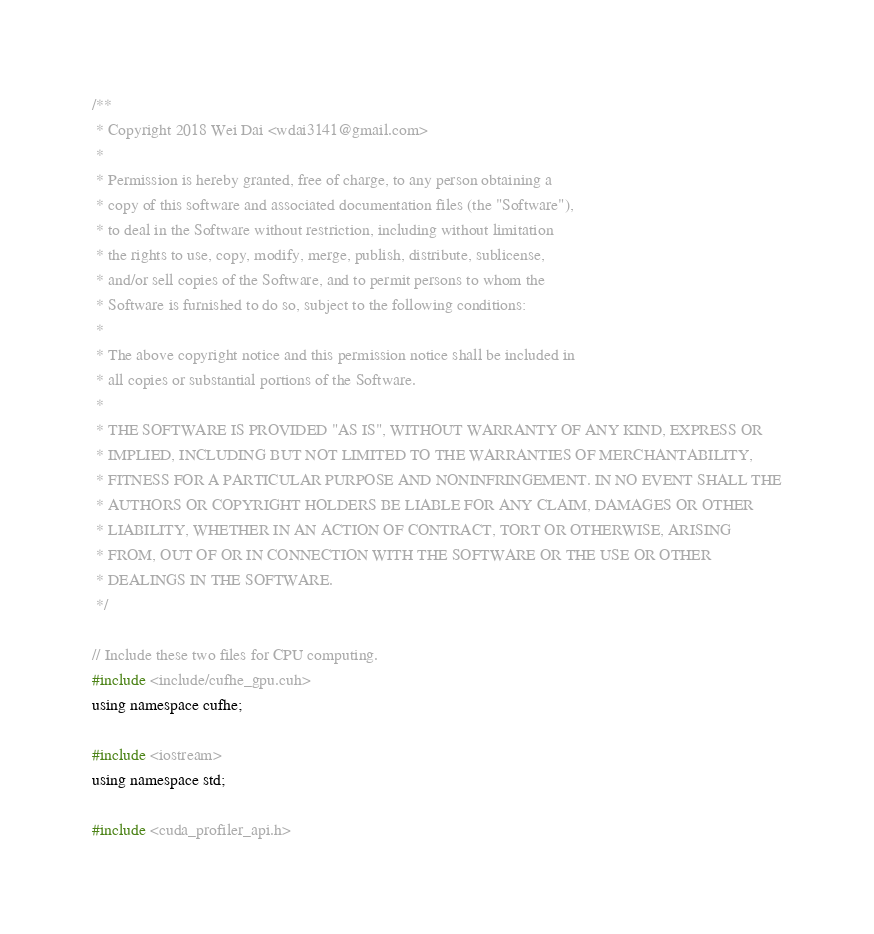Convert code to text. <code><loc_0><loc_0><loc_500><loc_500><_Cuda_>/**
 * Copyright 2018 Wei Dai <wdai3141@gmail.com>
 *
 * Permission is hereby granted, free of charge, to any person obtaining a
 * copy of this software and associated documentation files (the "Software"),
 * to deal in the Software without restriction, including without limitation
 * the rights to use, copy, modify, merge, publish, distribute, sublicense,
 * and/or sell copies of the Software, and to permit persons to whom the
 * Software is furnished to do so, subject to the following conditions:
 *
 * The above copyright notice and this permission notice shall be included in
 * all copies or substantial portions of the Software.
 *
 * THE SOFTWARE IS PROVIDED "AS IS", WITHOUT WARRANTY OF ANY KIND, EXPRESS OR
 * IMPLIED, INCLUDING BUT NOT LIMITED TO THE WARRANTIES OF MERCHANTABILITY,
 * FITNESS FOR A PARTICULAR PURPOSE AND NONINFRINGEMENT. IN NO EVENT SHALL THE
 * AUTHORS OR COPYRIGHT HOLDERS BE LIABLE FOR ANY CLAIM, DAMAGES OR OTHER
 * LIABILITY, WHETHER IN AN ACTION OF CONTRACT, TORT OR OTHERWISE, ARISING
 * FROM, OUT OF OR IN CONNECTION WITH THE SOFTWARE OR THE USE OR OTHER
 * DEALINGS IN THE SOFTWARE.
 */

// Include these two files for CPU computing.
#include <include/cufhe_gpu.cuh>
using namespace cufhe;

#include <iostream>
using namespace std;

#include <cuda_profiler_api.h>
</code> 